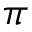Convert formula to latex. <formula><loc_0><loc_0><loc_500><loc_500>\pi</formula> 